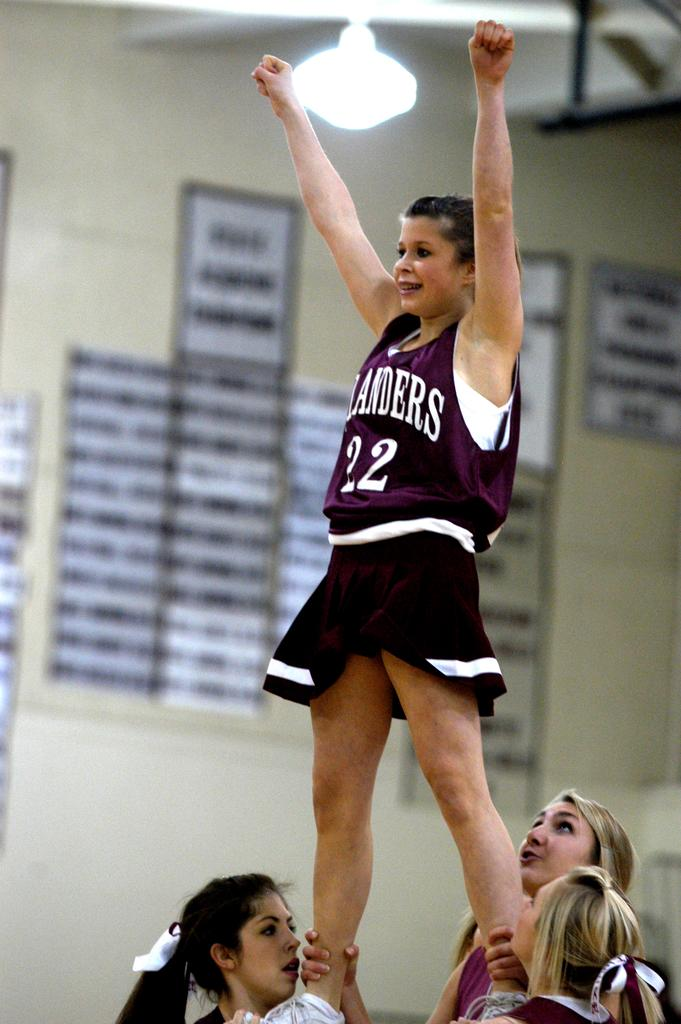<image>
Provide a brief description of the given image. the girl on the top is number 22 